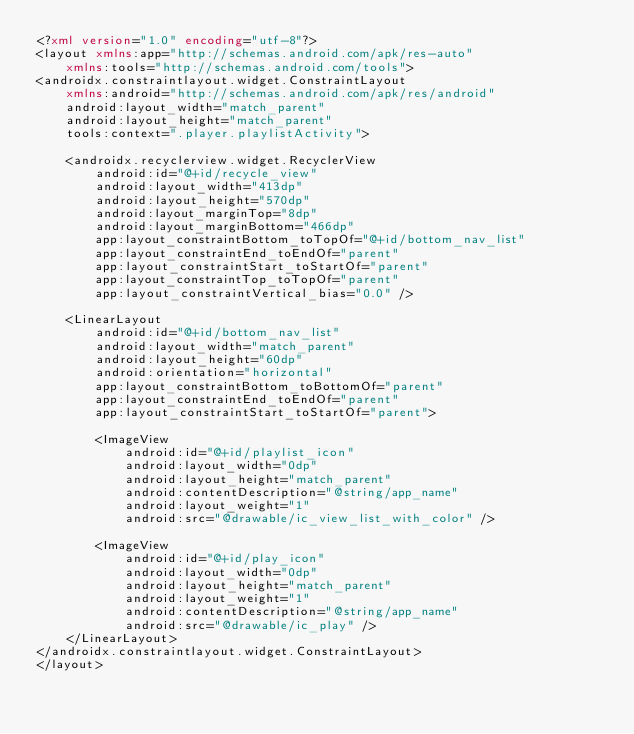Convert code to text. <code><loc_0><loc_0><loc_500><loc_500><_XML_><?xml version="1.0" encoding="utf-8"?>
<layout xmlns:app="http://schemas.android.com/apk/res-auto"
    xmlns:tools="http://schemas.android.com/tools">
<androidx.constraintlayout.widget.ConstraintLayout
    xmlns:android="http://schemas.android.com/apk/res/android"
    android:layout_width="match_parent"
    android:layout_height="match_parent"
    tools:context=".player.playlistActivity">

    <androidx.recyclerview.widget.RecyclerView
        android:id="@+id/recycle_view"
        android:layout_width="413dp"
        android:layout_height="570dp"
        android:layout_marginTop="8dp"
        android:layout_marginBottom="466dp"
        app:layout_constraintBottom_toTopOf="@+id/bottom_nav_list"
        app:layout_constraintEnd_toEndOf="parent"
        app:layout_constraintStart_toStartOf="parent"
        app:layout_constraintTop_toTopOf="parent"
        app:layout_constraintVertical_bias="0.0" />

    <LinearLayout
        android:id="@+id/bottom_nav_list"
        android:layout_width="match_parent"
        android:layout_height="60dp"
        android:orientation="horizontal"
        app:layout_constraintBottom_toBottomOf="parent"
        app:layout_constraintEnd_toEndOf="parent"
        app:layout_constraintStart_toStartOf="parent">

        <ImageView
            android:id="@+id/playlist_icon"
            android:layout_width="0dp"
            android:layout_height="match_parent"
            android:contentDescription="@string/app_name"
            android:layout_weight="1"
            android:src="@drawable/ic_view_list_with_color" />

        <ImageView
            android:id="@+id/play_icon"
            android:layout_width="0dp"
            android:layout_height="match_parent"
            android:layout_weight="1"
            android:contentDescription="@string/app_name"
            android:src="@drawable/ic_play" />
    </LinearLayout>
</androidx.constraintlayout.widget.ConstraintLayout>
</layout></code> 